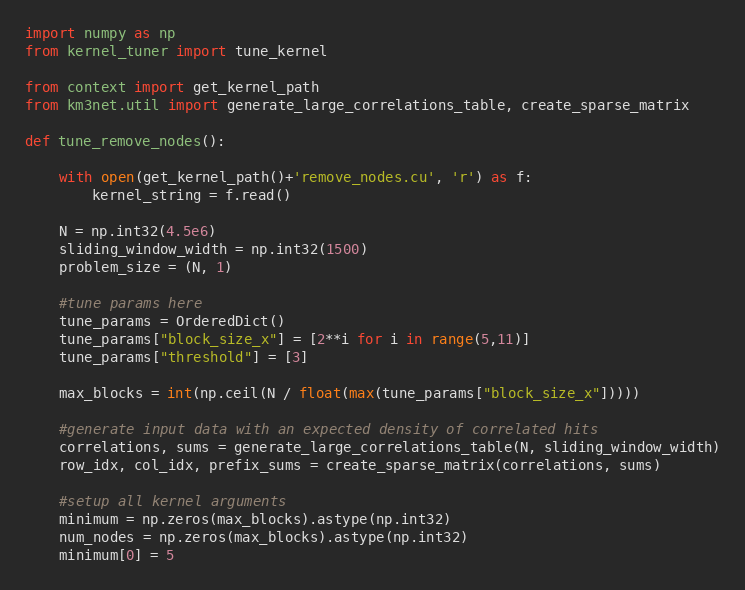Convert code to text. <code><loc_0><loc_0><loc_500><loc_500><_Python_>import numpy as np
from kernel_tuner import tune_kernel

from context import get_kernel_path
from km3net.util import generate_large_correlations_table, create_sparse_matrix

def tune_remove_nodes():

    with open(get_kernel_path()+'remove_nodes.cu', 'r') as f:
        kernel_string = f.read()

    N = np.int32(4.5e6)
    sliding_window_width = np.int32(1500)
    problem_size = (N, 1)

    #tune params here
    tune_params = OrderedDict()
    tune_params["block_size_x"] = [2**i for i in range(5,11)]
    tune_params["threshold"] = [3]

    max_blocks = int(np.ceil(N / float(max(tune_params["block_size_x"]))))

    #generate input data with an expected density of correlated hits
    correlations, sums = generate_large_correlations_table(N, sliding_window_width)
    row_idx, col_idx, prefix_sums = create_sparse_matrix(correlations, sums)

    #setup all kernel arguments
    minimum = np.zeros(max_blocks).astype(np.int32)
    num_nodes = np.zeros(max_blocks).astype(np.int32)
    minimum[0] = 5</code> 